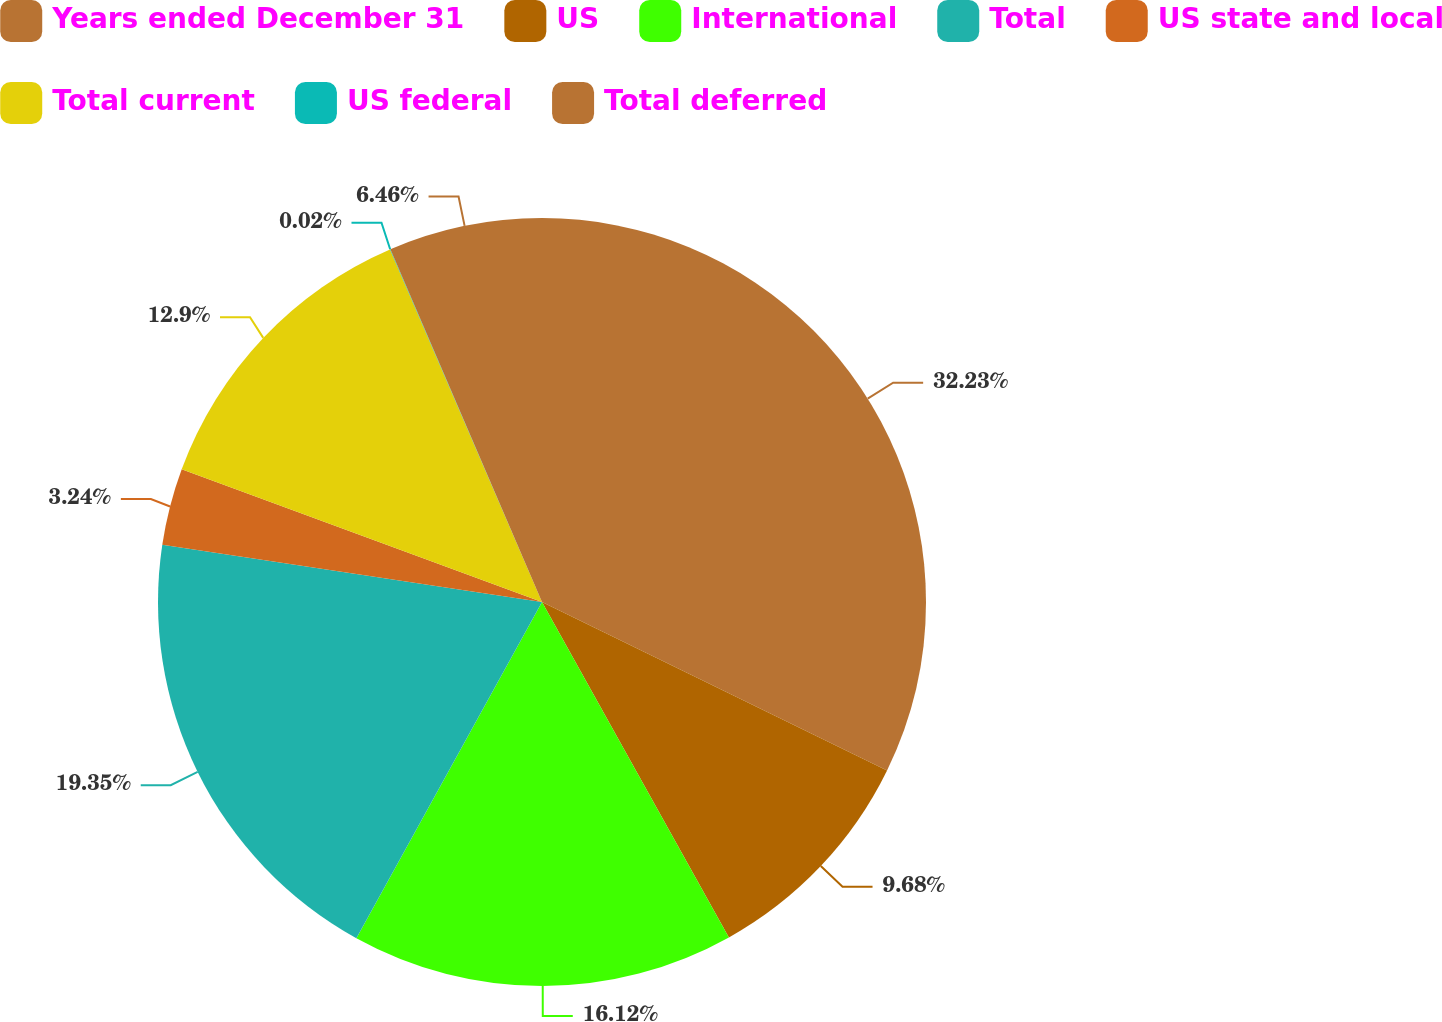Convert chart to OTSL. <chart><loc_0><loc_0><loc_500><loc_500><pie_chart><fcel>Years ended December 31<fcel>US<fcel>International<fcel>Total<fcel>US state and local<fcel>Total current<fcel>US federal<fcel>Total deferred<nl><fcel>32.23%<fcel>9.68%<fcel>16.12%<fcel>19.35%<fcel>3.24%<fcel>12.9%<fcel>0.02%<fcel>6.46%<nl></chart> 